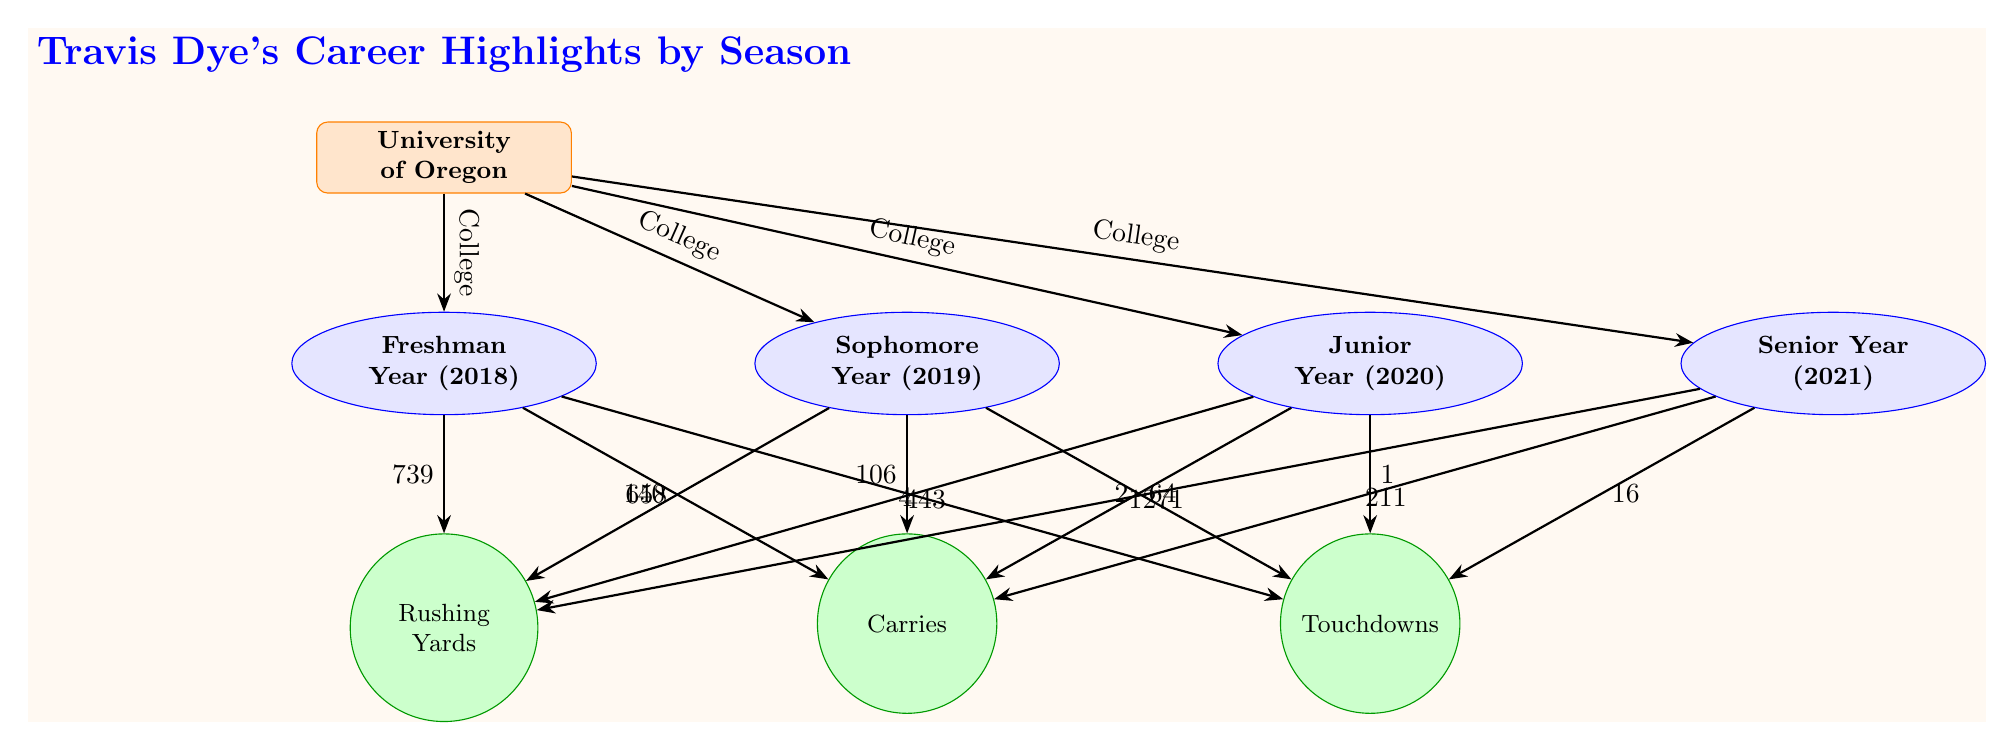What college did Travis Dye attend? The diagram indicates that Travis Dye attended the University of Oregon, which is labeled at the top of the diagram.
Answer: University of Oregon What was Travis Dye's rushing yards in his freshman year? The diagram displays a node connected to the freshman year label with the value 739 associated with rushing yards.
Answer: 739 How many carries did Travis Dye have in his sophomore year? In the diagram, there is a node linked to the sophomore year indicating he had 106 carries.
Answer: 106 Which season had the highest number of touchdowns? By comparing the touchdowns across the seasons in the diagram, the senior year shows the highest number with 16 touchdowns.
Answer: 16 What was the total number of rushing yards across all seasons? To find the total, we add the rushing yards from each season: 739 (freshman) + 658 (sophomore) + 443 (junior) + 1271 (senior) = 3111.
Answer: 3111 In which year did Travis Dye have the least rushing yards? Examining the rushing yards values, the junior year has the lowest at 443 rushing yards.
Answer: Junior Year (2020) How many touchdowns did Travis Dye score in his junior year? The diagram indicates that Travis Dye scored 1 touchdown in his junior year as represented by the node linked to that season.
Answer: 1 What is the relationship between the college node and the seasons? The college node is connected to each season node by arrows indicating that these seasons represent the college football career under that college.
Answer: College Which season had the most carries? Referring to the carries listed under each season, the senior year shows the highest at 211 carries.
Answer: Senior Year (2021) 